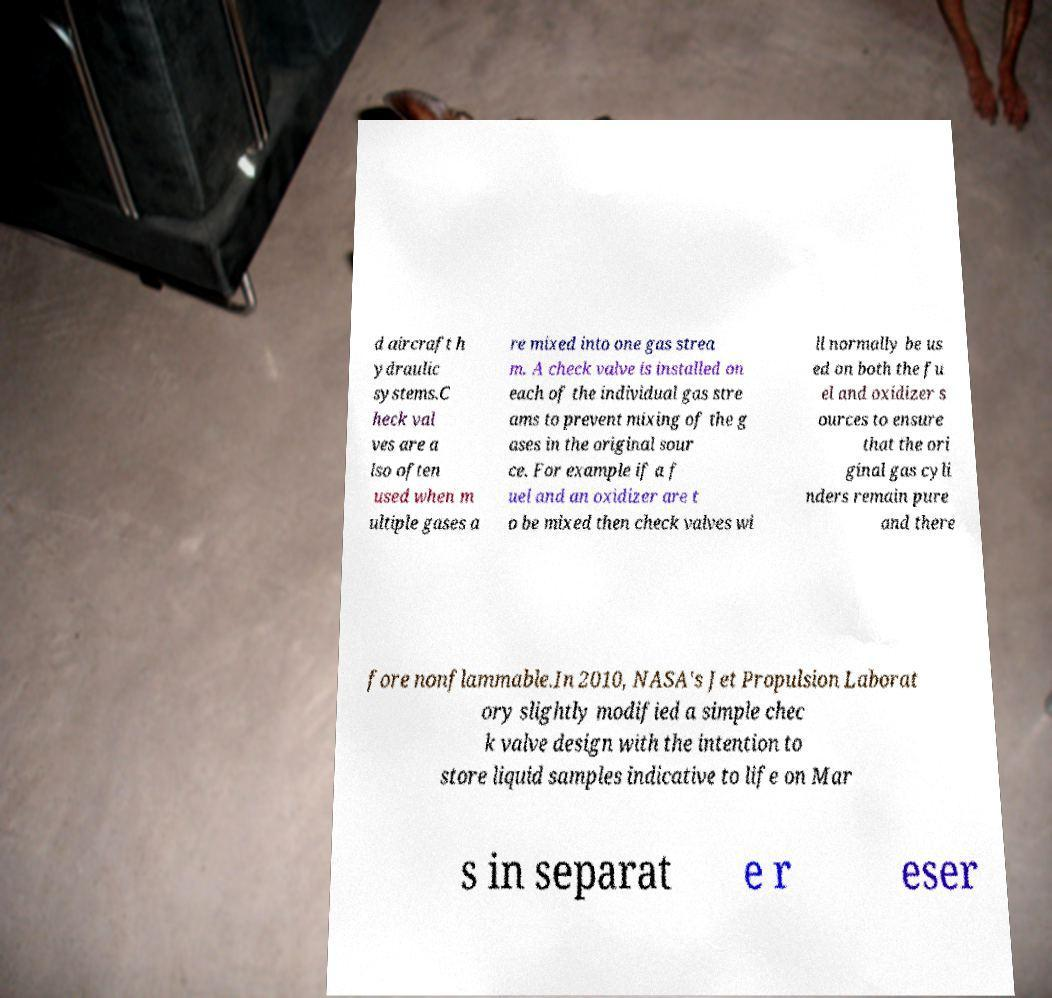Could you assist in decoding the text presented in this image and type it out clearly? d aircraft h ydraulic systems.C heck val ves are a lso often used when m ultiple gases a re mixed into one gas strea m. A check valve is installed on each of the individual gas stre ams to prevent mixing of the g ases in the original sour ce. For example if a f uel and an oxidizer are t o be mixed then check valves wi ll normally be us ed on both the fu el and oxidizer s ources to ensure that the ori ginal gas cyli nders remain pure and there fore nonflammable.In 2010, NASA's Jet Propulsion Laborat ory slightly modified a simple chec k valve design with the intention to store liquid samples indicative to life on Mar s in separat e r eser 